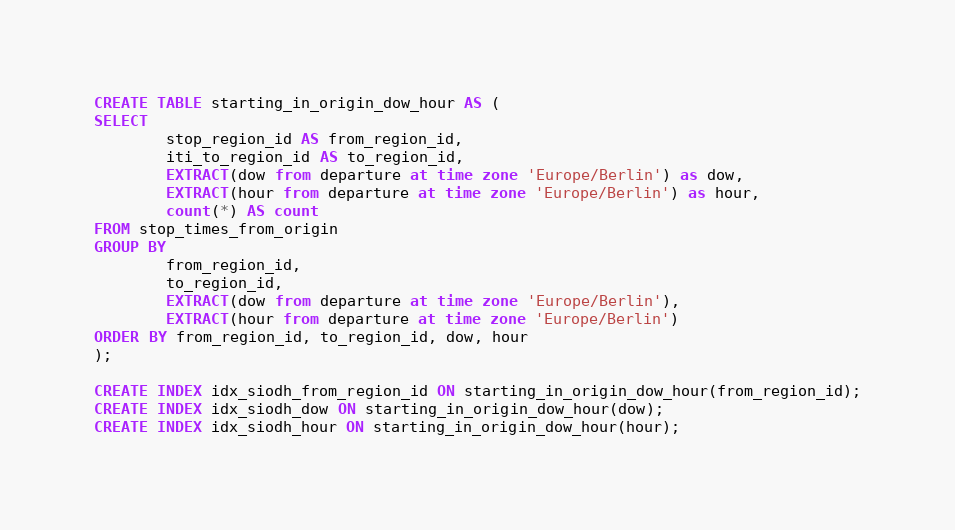<code> <loc_0><loc_0><loc_500><loc_500><_SQL_>CREATE TABLE starting_in_origin_dow_hour AS (
SELECT
        stop_region_id AS from_region_id,
        iti_to_region_id AS to_region_id,
        EXTRACT(dow from departure at time zone 'Europe/Berlin') as dow,
        EXTRACT(hour from departure at time zone 'Europe/Berlin') as hour,
        count(*) AS count
FROM stop_times_from_origin
GROUP BY
        from_region_id,
        to_region_id,
        EXTRACT(dow from departure at time zone 'Europe/Berlin'),
        EXTRACT(hour from departure at time zone 'Europe/Berlin')
ORDER BY from_region_id, to_region_id, dow, hour
);

CREATE INDEX idx_siodh_from_region_id ON starting_in_origin_dow_hour(from_region_id);
CREATE INDEX idx_siodh_dow ON starting_in_origin_dow_hour(dow);
CREATE INDEX idx_siodh_hour ON starting_in_origin_dow_hour(hour);
</code> 